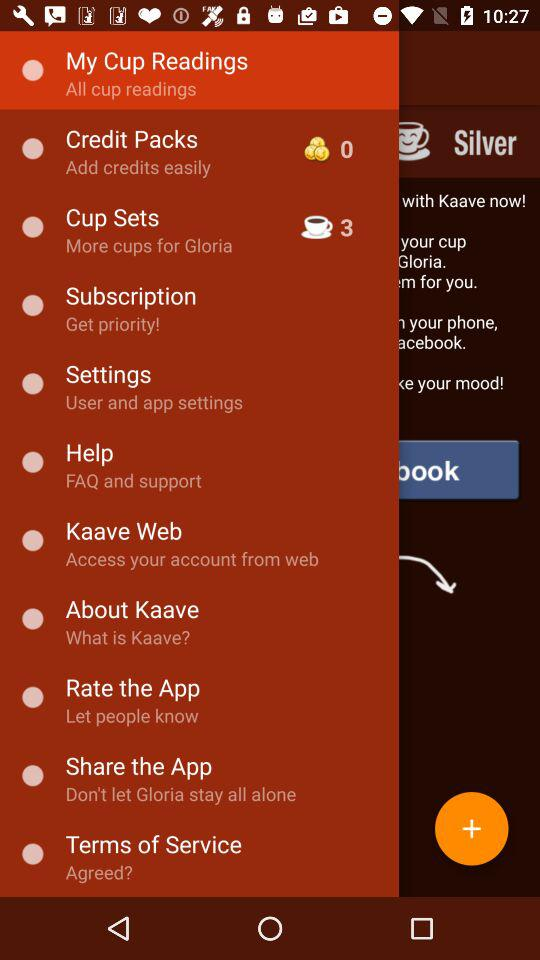How many cup sets are there? There are 3 cup sets. 